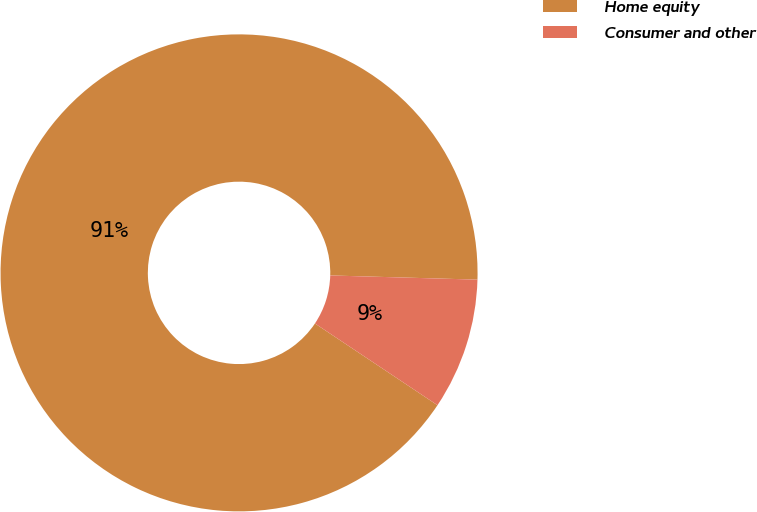Convert chart to OTSL. <chart><loc_0><loc_0><loc_500><loc_500><pie_chart><fcel>Home equity<fcel>Consumer and other<nl><fcel>91.09%<fcel>8.91%<nl></chart> 